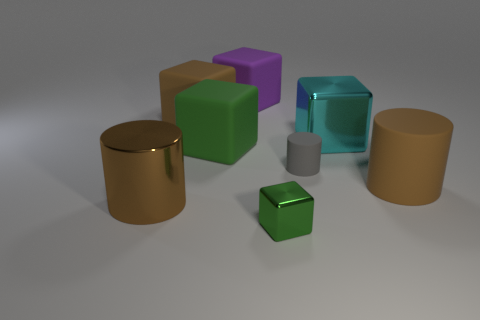The shiny object that is the same color as the large rubber cylinder is what shape?
Provide a succinct answer. Cylinder. There is a green rubber block; are there any large brown objects behind it?
Provide a short and direct response. Yes. What number of objects are shiny objects to the right of the small green block or small gray matte cylinders?
Make the answer very short. 2. There is a big rubber block in front of the big metallic cube; what number of brown cylinders are behind it?
Make the answer very short. 0. Is the number of rubber blocks in front of the large brown metallic object less than the number of large cyan metal things in front of the big cyan thing?
Give a very brief answer. No. What is the shape of the brown thing that is in front of the big brown cylinder that is to the right of the cyan thing?
Your answer should be very brief. Cylinder. What number of other objects are there of the same material as the purple object?
Your response must be concise. 4. Is there anything else that has the same size as the purple matte block?
Keep it short and to the point. Yes. Is the number of brown cubes greater than the number of big rubber cubes?
Your answer should be very brief. No. What is the size of the brown rubber object that is behind the green object that is behind the large brown cylinder that is on the left side of the large cyan block?
Offer a terse response. Large. 